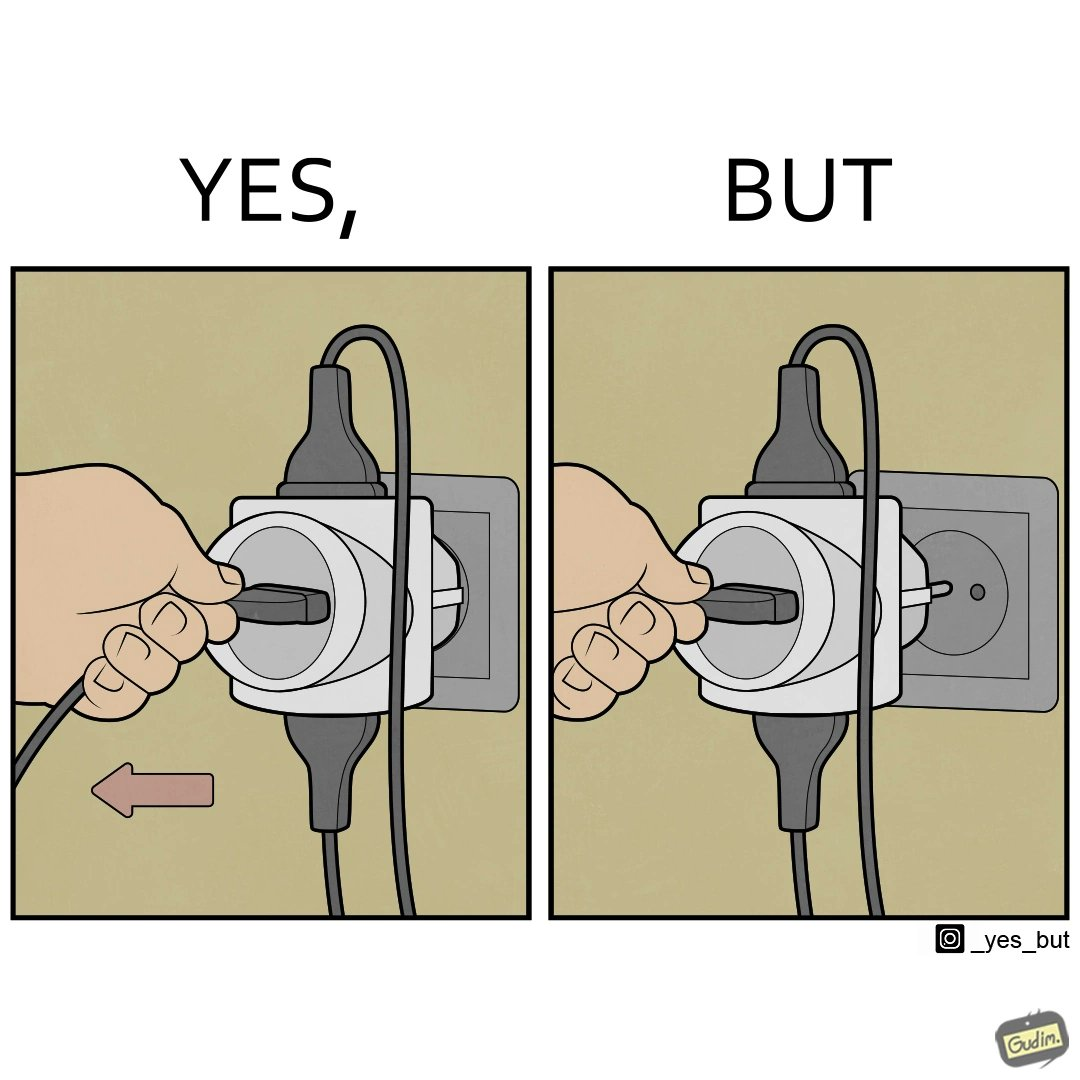What is the satirical meaning behind this image? The image is ironic, because some person is trying to plug out one pin from the multi pin plug but due to tight fitting the multi pin plug socket itself is getting pulled off disconnecting the power supply to other devices even when it is not required 